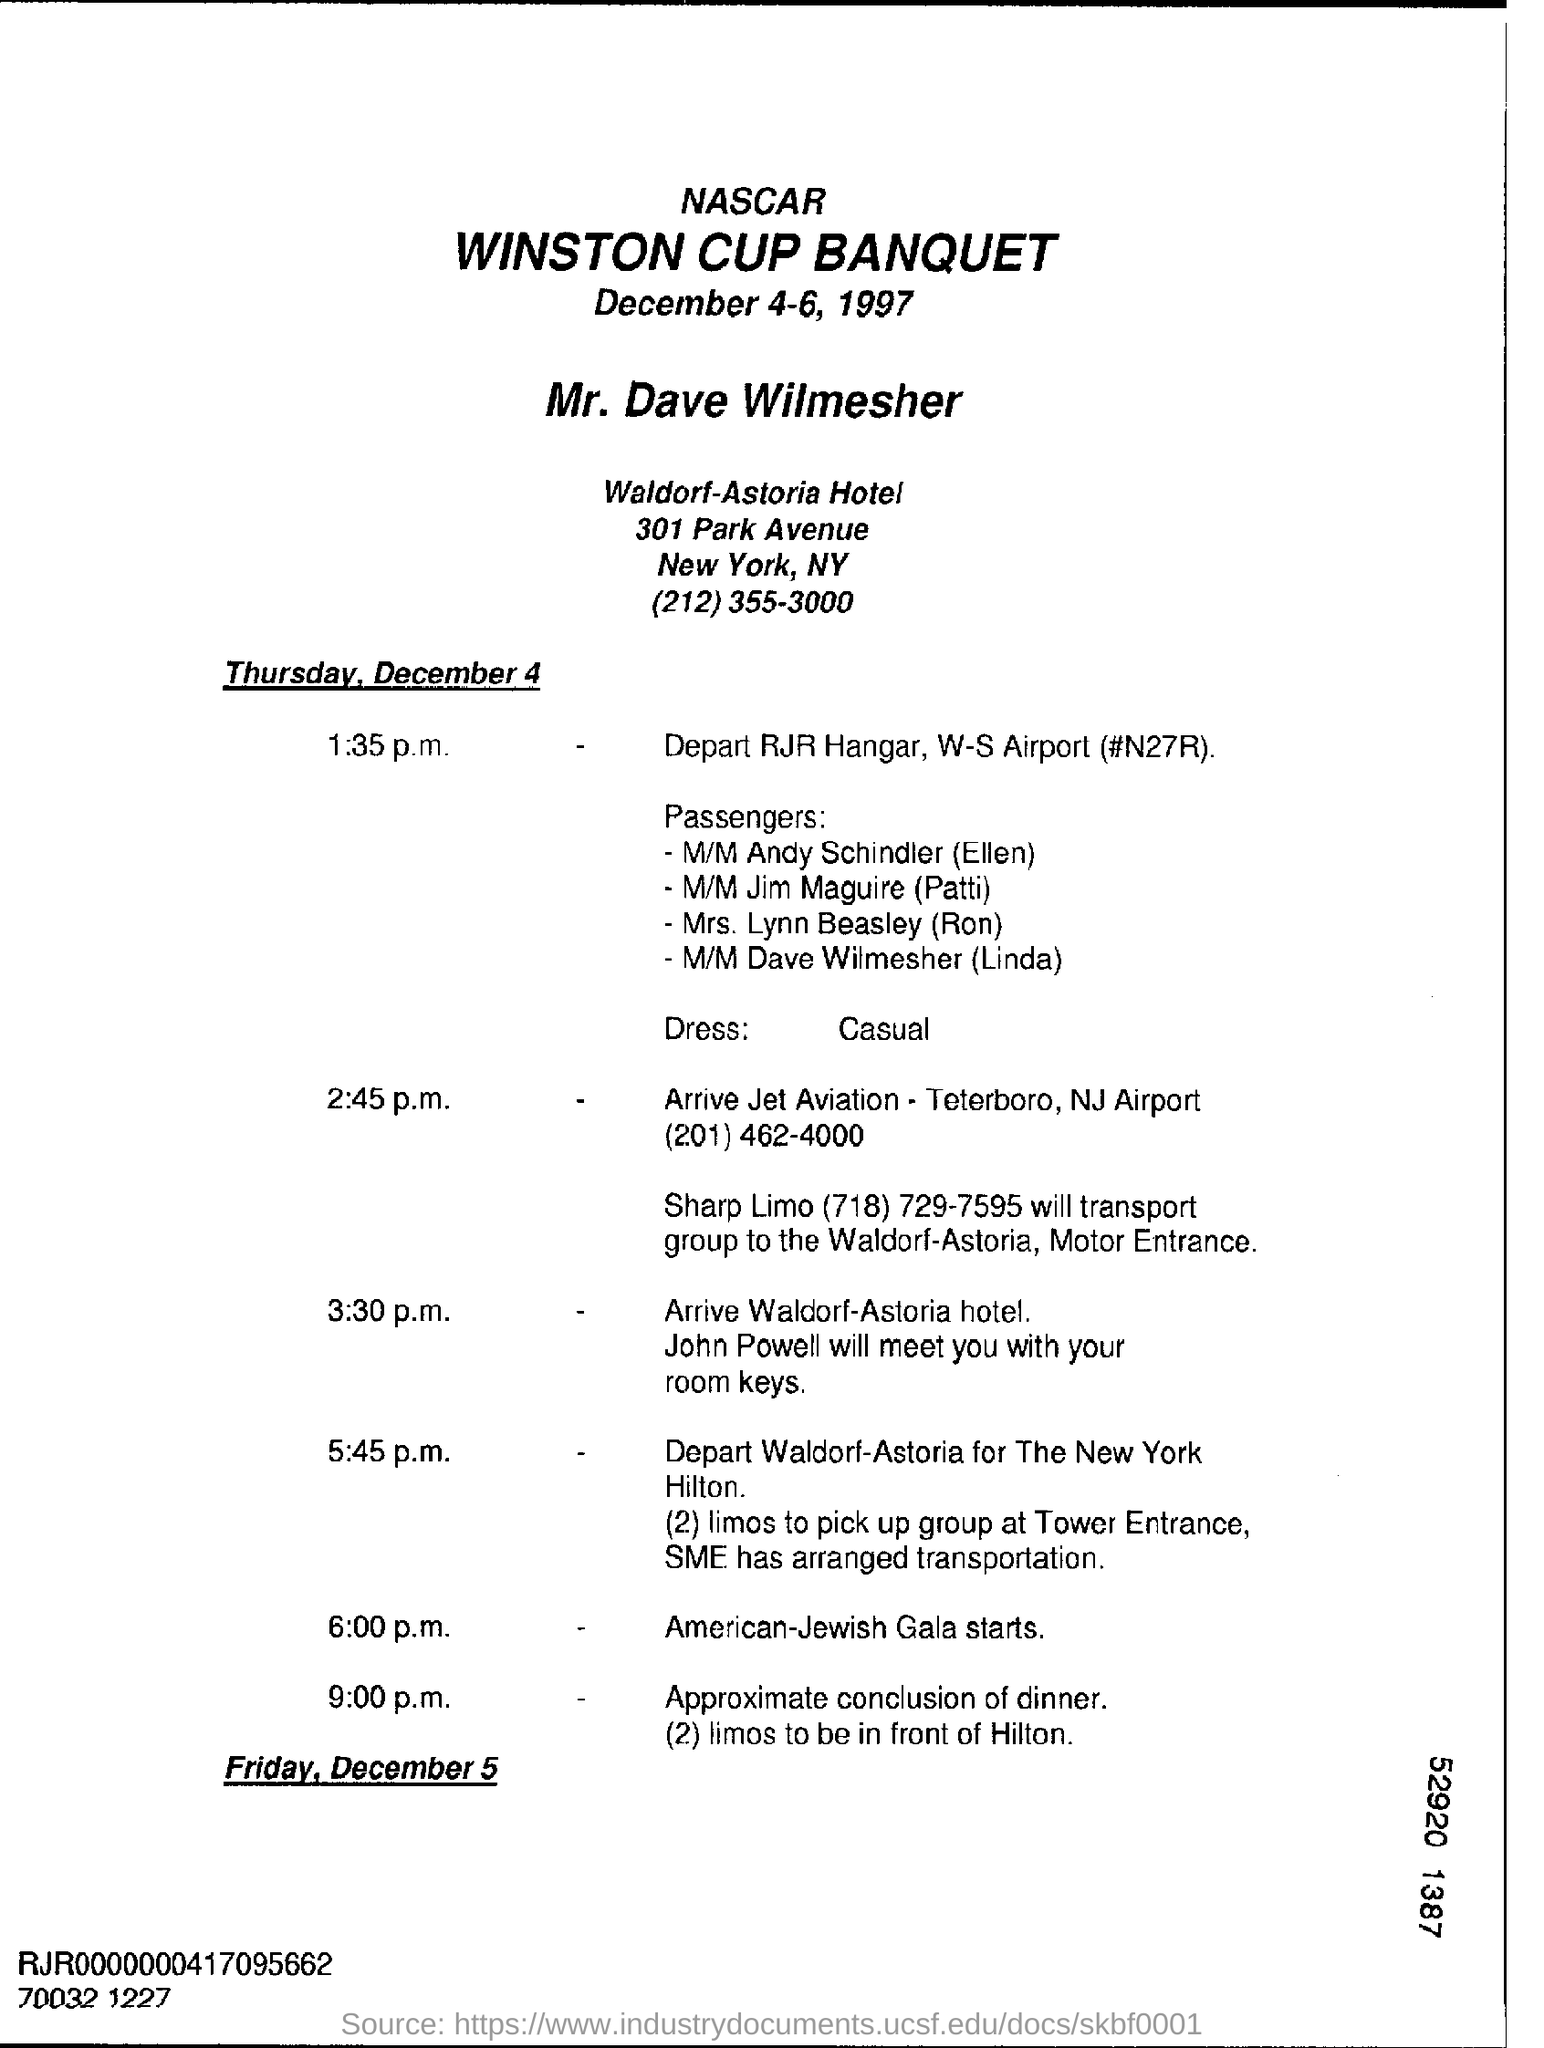When is the Winston Cup Banquet to be conducted?
Offer a terse response. December 4-6, 1997. At what time the American-Jewish Gala starts?
Provide a short and direct response. 6:00 p.m. What is the name of the hotel?
Ensure brevity in your answer.  Waldorf-Astoria Hotel. 